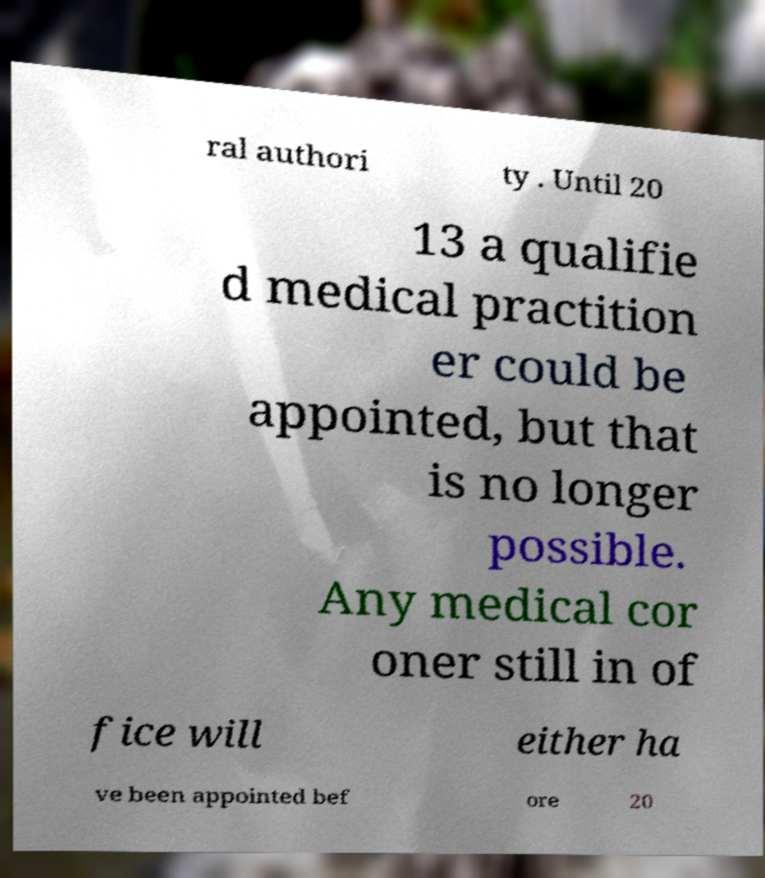Please identify and transcribe the text found in this image. ral authori ty . Until 20 13 a qualifie d medical practition er could be appointed, but that is no longer possible. Any medical cor oner still in of fice will either ha ve been appointed bef ore 20 